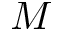Convert formula to latex. <formula><loc_0><loc_0><loc_500><loc_500>M</formula> 